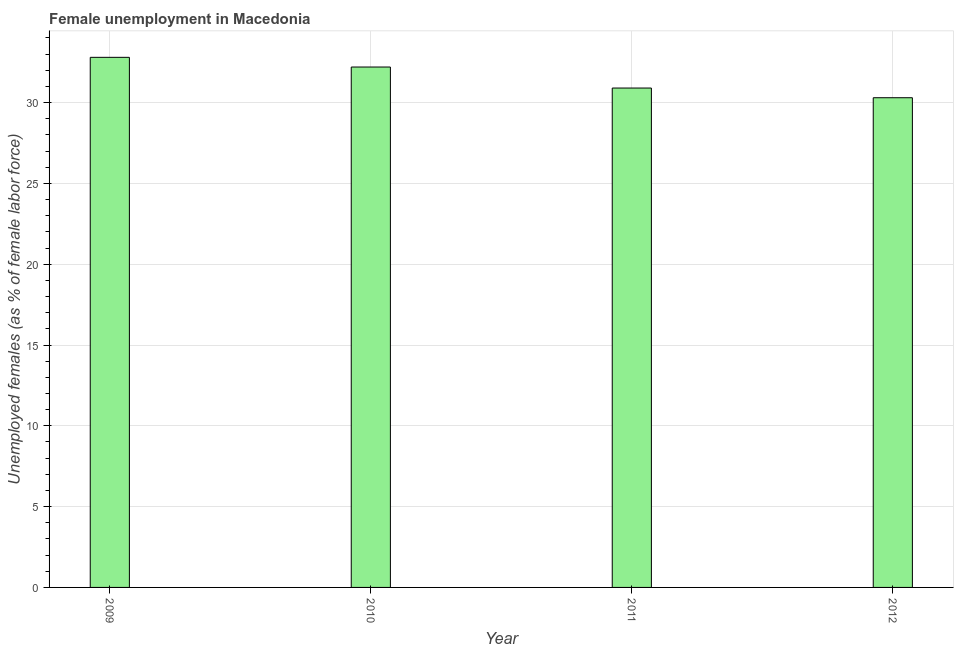Does the graph contain any zero values?
Give a very brief answer. No. Does the graph contain grids?
Make the answer very short. Yes. What is the title of the graph?
Your response must be concise. Female unemployment in Macedonia. What is the label or title of the X-axis?
Your response must be concise. Year. What is the label or title of the Y-axis?
Offer a terse response. Unemployed females (as % of female labor force). What is the unemployed females population in 2010?
Provide a succinct answer. 32.2. Across all years, what is the maximum unemployed females population?
Ensure brevity in your answer.  32.8. Across all years, what is the minimum unemployed females population?
Your answer should be very brief. 30.3. In which year was the unemployed females population minimum?
Offer a very short reply. 2012. What is the sum of the unemployed females population?
Keep it short and to the point. 126.2. What is the difference between the unemployed females population in 2009 and 2012?
Give a very brief answer. 2.5. What is the average unemployed females population per year?
Your answer should be compact. 31.55. What is the median unemployed females population?
Provide a succinct answer. 31.55. What is the ratio of the unemployed females population in 2009 to that in 2012?
Your response must be concise. 1.08. Is the unemployed females population in 2011 less than that in 2012?
Offer a very short reply. No. Is the difference between the unemployed females population in 2010 and 2012 greater than the difference between any two years?
Your answer should be compact. No. What is the difference between the highest and the second highest unemployed females population?
Offer a terse response. 0.6. What is the difference between the highest and the lowest unemployed females population?
Provide a succinct answer. 2.5. How many bars are there?
Your answer should be very brief. 4. Are all the bars in the graph horizontal?
Give a very brief answer. No. Are the values on the major ticks of Y-axis written in scientific E-notation?
Provide a succinct answer. No. What is the Unemployed females (as % of female labor force) in 2009?
Your response must be concise. 32.8. What is the Unemployed females (as % of female labor force) in 2010?
Make the answer very short. 32.2. What is the Unemployed females (as % of female labor force) of 2011?
Provide a succinct answer. 30.9. What is the Unemployed females (as % of female labor force) in 2012?
Provide a short and direct response. 30.3. What is the difference between the Unemployed females (as % of female labor force) in 2009 and 2010?
Offer a terse response. 0.6. What is the difference between the Unemployed females (as % of female labor force) in 2009 and 2011?
Provide a short and direct response. 1.9. What is the difference between the Unemployed females (as % of female labor force) in 2010 and 2012?
Give a very brief answer. 1.9. What is the ratio of the Unemployed females (as % of female labor force) in 2009 to that in 2010?
Keep it short and to the point. 1.02. What is the ratio of the Unemployed females (as % of female labor force) in 2009 to that in 2011?
Your answer should be very brief. 1.06. What is the ratio of the Unemployed females (as % of female labor force) in 2009 to that in 2012?
Offer a very short reply. 1.08. What is the ratio of the Unemployed females (as % of female labor force) in 2010 to that in 2011?
Keep it short and to the point. 1.04. What is the ratio of the Unemployed females (as % of female labor force) in 2010 to that in 2012?
Keep it short and to the point. 1.06. 